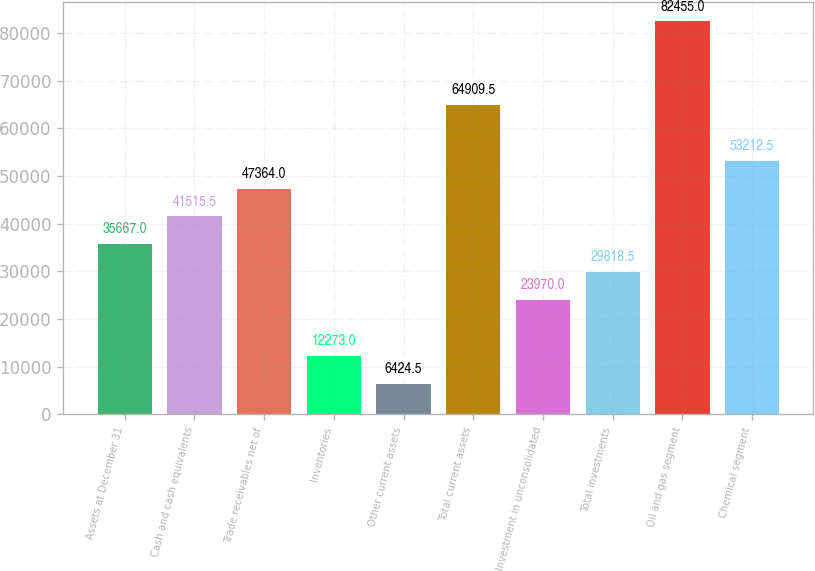<chart> <loc_0><loc_0><loc_500><loc_500><bar_chart><fcel>Assets at December 31<fcel>Cash and cash equivalents<fcel>Trade receivables net of<fcel>Inventories<fcel>Other current assets<fcel>Total current assets<fcel>Investment in unconsolidated<fcel>Total investments<fcel>Oil and gas segment<fcel>Chemical segment<nl><fcel>35667<fcel>41515.5<fcel>47364<fcel>12273<fcel>6424.5<fcel>64909.5<fcel>23970<fcel>29818.5<fcel>82455<fcel>53212.5<nl></chart> 